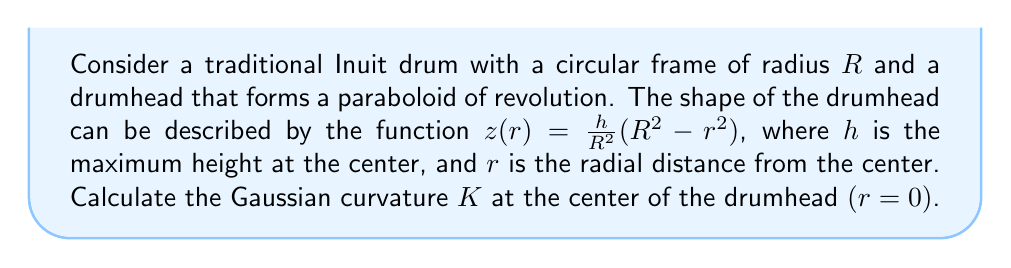Can you solve this math problem? To analyze the curvature of the Inuit drum shape using differential geometry, we'll follow these steps:

1) First, we need to parametrize the surface. Given the function $z(r) = \frac{h}{R^2}(R^2 - r^2)$, we can use cylindrical coordinates to parametrize the surface:

   $x(r,\theta) = r\cos\theta$
   $y(r,\theta) = r\sin\theta$
   $z(r,\theta) = \frac{h}{R^2}(R^2 - r^2)$

2) To calculate the Gaussian curvature, we need to compute the first and second fundamental forms. Let's start by calculating the partial derivatives:

   $\mathbf{r}_r = (\cos\theta, \sin\theta, -\frac{2hr}{R^2})$
   $\mathbf{r}_\theta = (-r\sin\theta, r\cos\theta, 0)$

   $\mathbf{r}_{rr} = (0, 0, -\frac{2h}{R^2})$
   $\mathbf{r}_{r\theta} = (-\sin\theta, \cos\theta, 0)$
   $\mathbf{r}_{\theta\theta} = (-r\cos\theta, -r\sin\theta, 0)$

3) Now we can compute the coefficients of the first fundamental form:

   $E = \mathbf{r}_r \cdot \mathbf{r}_r = 1 + (\frac{2hr}{R^2})^2$
   $F = \mathbf{r}_r \cdot \mathbf{r}_\theta = 0$
   $G = \mathbf{r}_\theta \cdot \mathbf{r}_\theta = r^2$

4) And the coefficients of the second fundamental form:

   $L = \frac{\mathbf{r}_r \times \mathbf{r}_\theta \cdot \mathbf{r}_{rr}}{\sqrt{EG-F^2}} = \frac{2h}{R^2\sqrt{1 + (\frac{2hr}{R^2})^2}}$
   $M = \frac{\mathbf{r}_r \times \mathbf{r}_\theta \cdot \mathbf{r}_{r\theta}}{\sqrt{EG-F^2}} = 0$
   $N = \frac{\mathbf{r}_r \times \mathbf{r}_\theta \cdot \mathbf{r}_{\theta\theta}}{\sqrt{EG-F^2}} = \frac{2hr}{R^2\sqrt{1 + (\frac{2hr}{R^2})^2}}$

5) The Gaussian curvature is given by:

   $K = \frac{LN - M^2}{EG - F^2}$

6) At the center of the drumhead, $r=0$. Evaluating the coefficients at this point:

   $E = 1$, $F = 0$, $G = 0$
   $L = \frac{2h}{R^2}$, $M = 0$, $N = 0$

7) Substituting these values into the formula for Gaussian curvature:

   $K = \frac{(\frac{2h}{R^2})(0) - 0^2}{(1)(0) - 0^2} = \frac{0}{0}$

   This is an indeterminate form. We need to use L'Hôpital's rule or consider the limit as $r$ approaches 0.

8) Taking the limit as $r$ approaches 0:

   $\lim_{r\to0} K = \lim_{r\to0} \frac{LN - M^2}{EG - F^2} = \lim_{r\to0} \frac{(\frac{2h}{R^2})(\frac{2hr}{R^2}) - 0^2}{(1)(r^2) - 0^2} = \frac{4h^2}{R^4}$

Therefore, the Gaussian curvature at the center of the drumhead is $\frac{4h^2}{R^4}$.
Answer: The Gaussian curvature $K$ at the center of the drumhead $(r=0)$ is $\frac{4h^2}{R^4}$. 